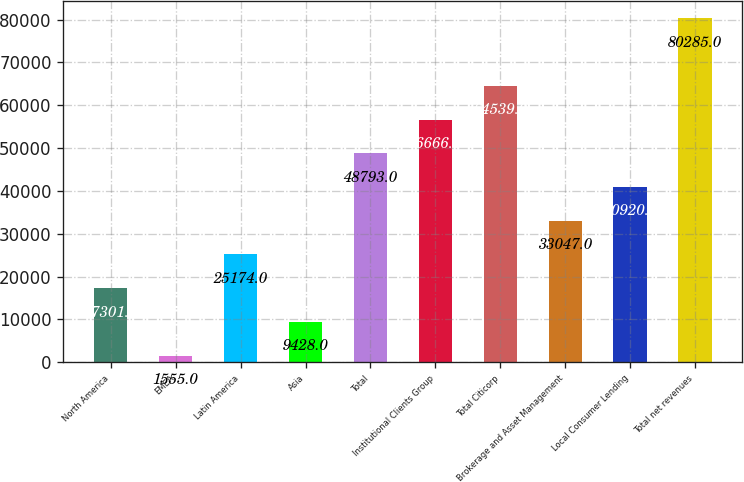<chart> <loc_0><loc_0><loc_500><loc_500><bar_chart><fcel>North America<fcel>EMEA<fcel>Latin America<fcel>Asia<fcel>Total<fcel>Institutional Clients Group<fcel>Total Citicorp<fcel>Brokerage and Asset Management<fcel>Local Consumer Lending<fcel>Total net revenues<nl><fcel>17301<fcel>1555<fcel>25174<fcel>9428<fcel>48793<fcel>56666<fcel>64539<fcel>33047<fcel>40920<fcel>80285<nl></chart> 